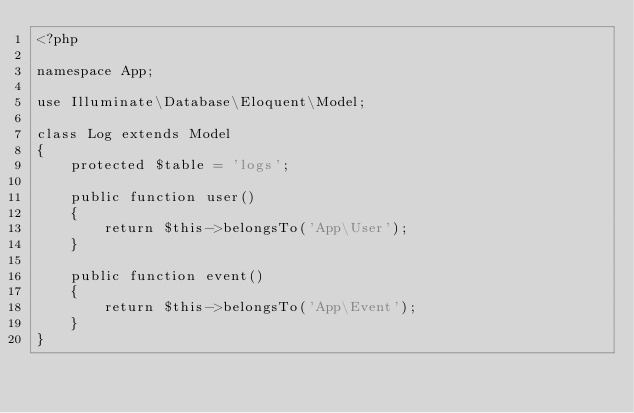<code> <loc_0><loc_0><loc_500><loc_500><_PHP_><?php

namespace App;

use Illuminate\Database\Eloquent\Model;

class Log extends Model
{
    protected $table = 'logs';

    public function user()
    {
        return $this->belongsTo('App\User');
    }

    public function event()
    {
        return $this->belongsTo('App\Event');
    }
}
</code> 